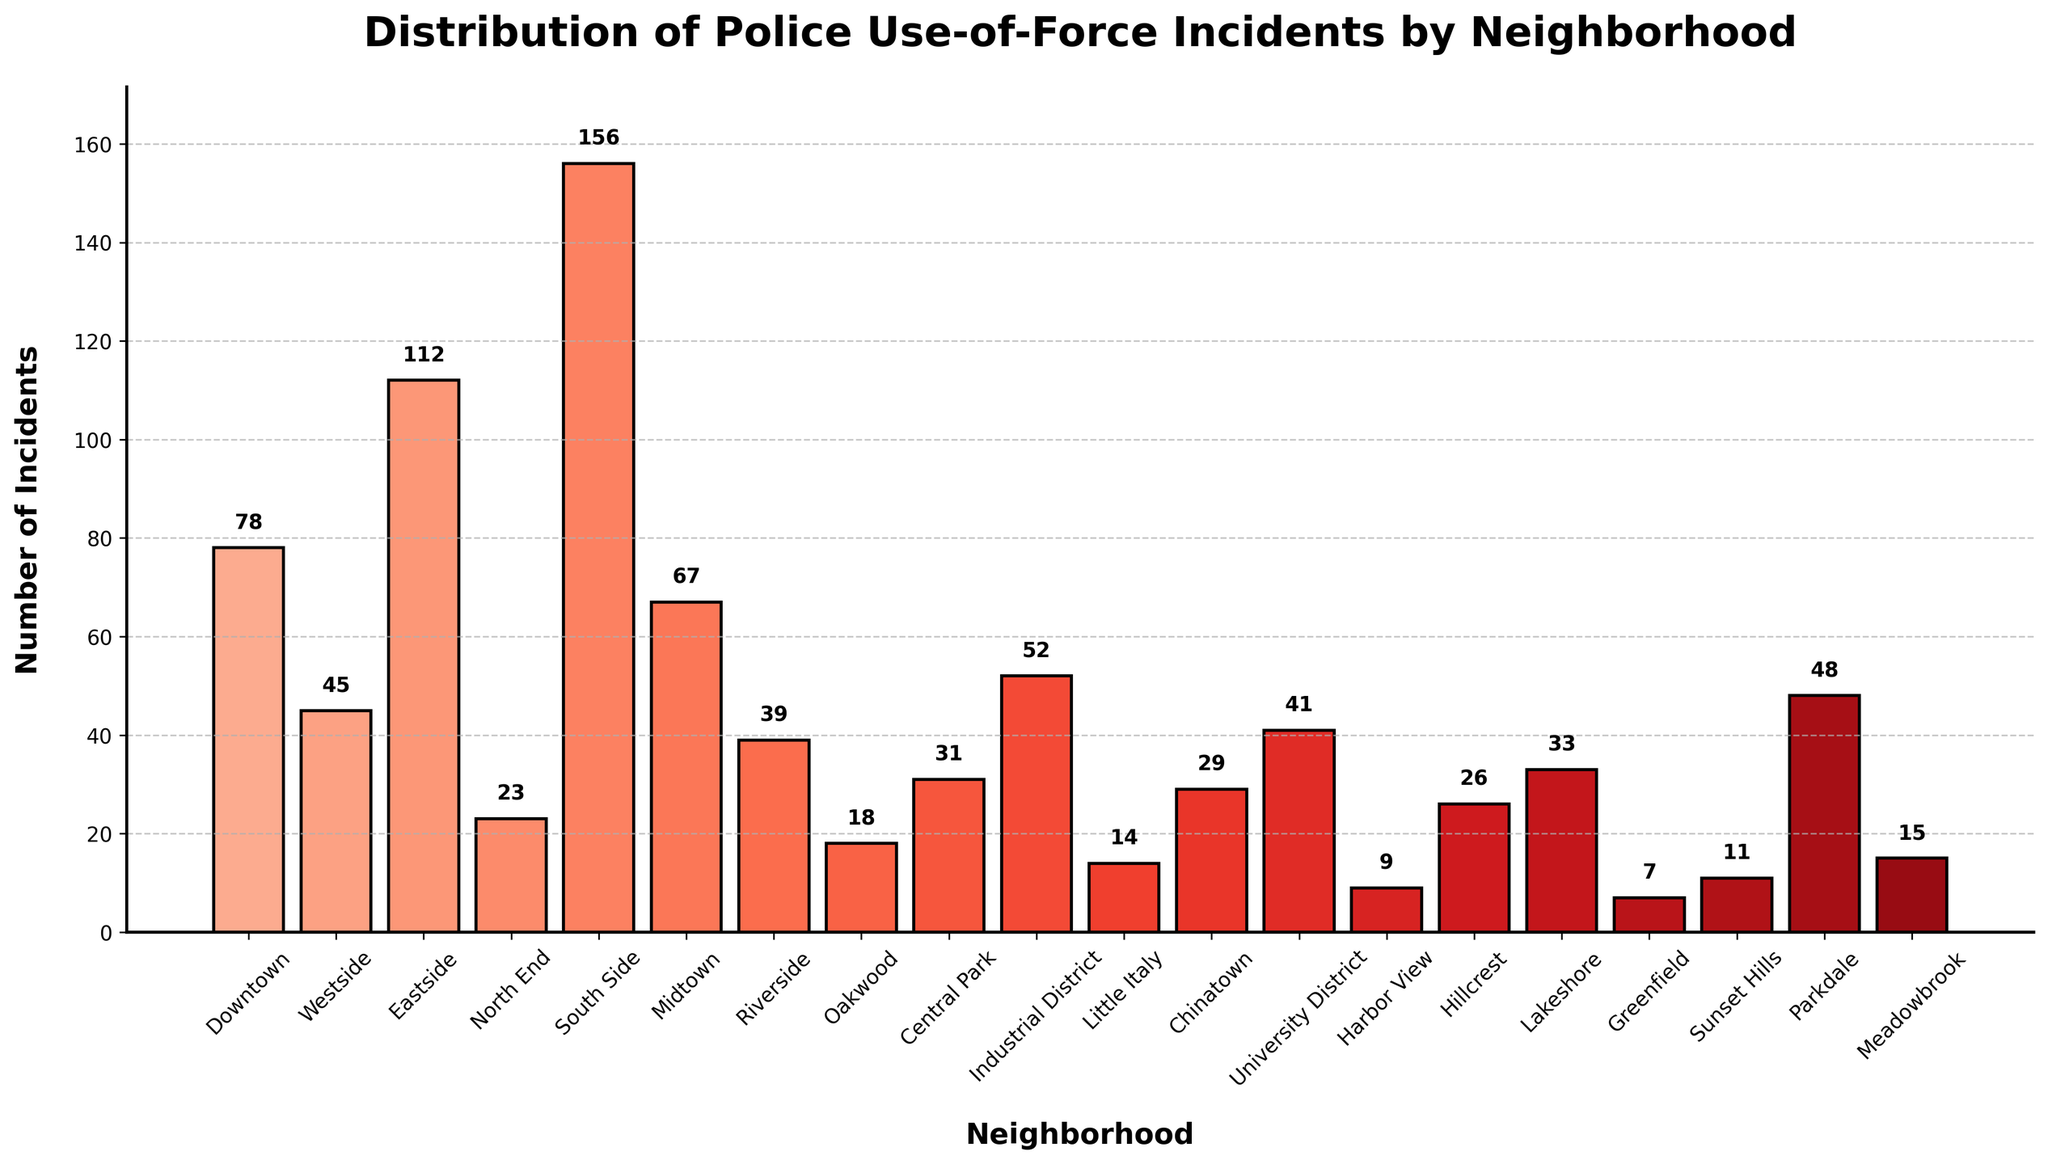Which neighborhood has the highest number of use-of-force incidents? The bar for South Side is the tallest in the bar chart, indicating the highest number of incidents.
Answer: South Side How many neighborhoods have fewer than 20 use-of-force incidents? The bars for Harbor View, Greenfield, Oakwood, Little Italy, Sunset Hills, and Meadowbrook all correspond to fewer than 20 incidents. Counting these gives us six neighborhoods.
Answer: 6 Which neighborhoods have more use-of-force incidents than Westside but fewer than Eastside? Comparing the heights of the bars, Midtown and Parkdale have more incidents than Westside (45) but fewer than Eastside (112).
Answer: Midtown, Parkdale What is the total number of use-of-force incidents across all neighborhoods? Sum all the provided data values: 78+45+112+23+156+67+39+18+31+52+14+29+41+9+26+33+7+11+48+15 = 855.
Answer: 855 Which neighborhood has the fewest use-of-force incidents, and how many are there? The bar for Greenfield is the shortest, indicating the lowest number of incidents.
Answer: Greenfield, 7 Is the use-of-force in Central Park more than or less than in University District? The bar for Central Park is shorter than the bar for University District, indicating fewer incidents.
Answer: Less By how many incidents does Eastside exceed Downtown in use-of-force cases? Subtract the incidents in Downtown from those in Eastside: 112 - 78 = 34.
Answer: 34 What is the combined total of use-of-force incidents in the three neighborhoods with the highest incidents? The three tallest bars are South Side (156), Eastside (112), and Downtown (78). Summing these: 156 + 112 + 78 = 346.
Answer: 346 What is the average number of use-of-force incidents across all neighborhoods? Total sum of 855 incidents divided by the number of neighborhoods (20): 855 / 20 = 42.75.
Answer: 42.75 